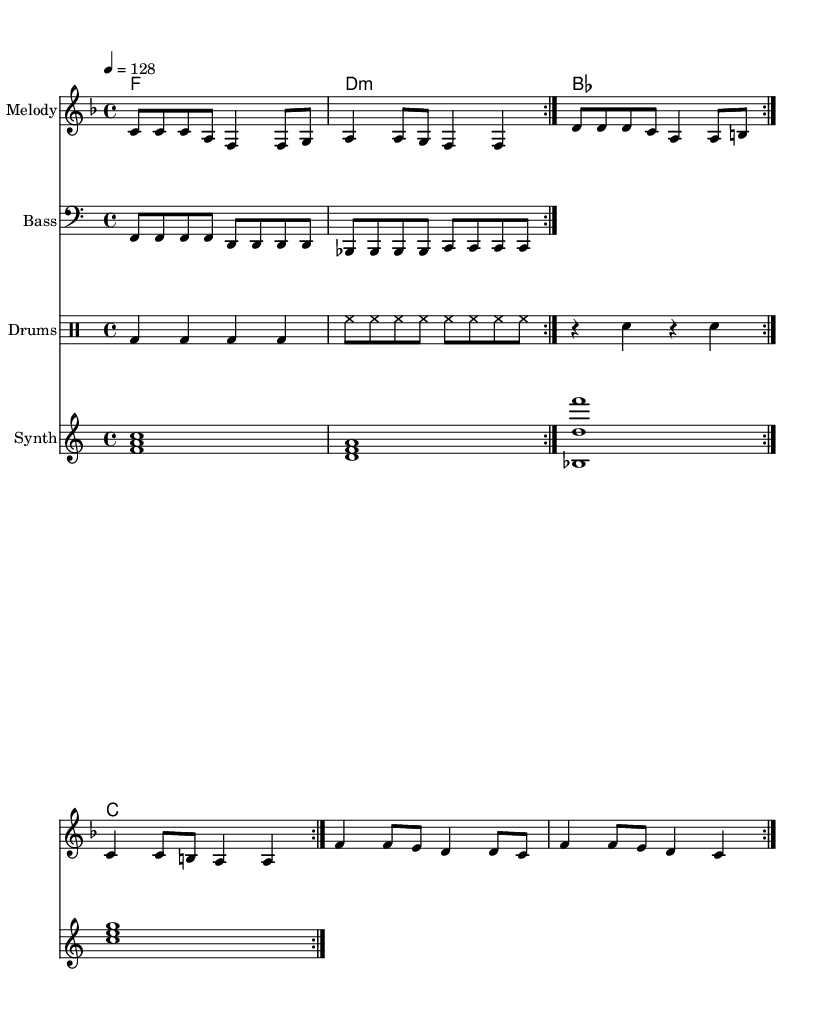What is the key signature of this music? The key signature is F major, which has one flat (B flat).
Answer: F major What is the time signature of this music? The time signature is 4/4, which means there are four beats per measure.
Answer: 4/4 What is the indicated tempo of this piece? The tempo is indicated as quarter note equals 128 beats per minute.
Answer: 128 How many measures are there in the melody before it repeats? The melody consists of 8 measures before it repeats. You can count the measures in the repeat section.
Answer: 8 What is the primary theme of the lyrics? The primary theme of the lyrics is data protection and digital rights, emphasizing the importance of privacy.
Answer: Data protection and digital rights How many different chords are used in the harmonies section? There are four different chords used: F major, D minor, B flat major, and C major. Count the unique chords in the chord progression.
Answer: Four What instruments are included in this music score? The instruments included are Melody, Bass, Drums, and Synth. You can see them listed in the score sections.
Answer: Melody, Bass, Drums, and Synth 